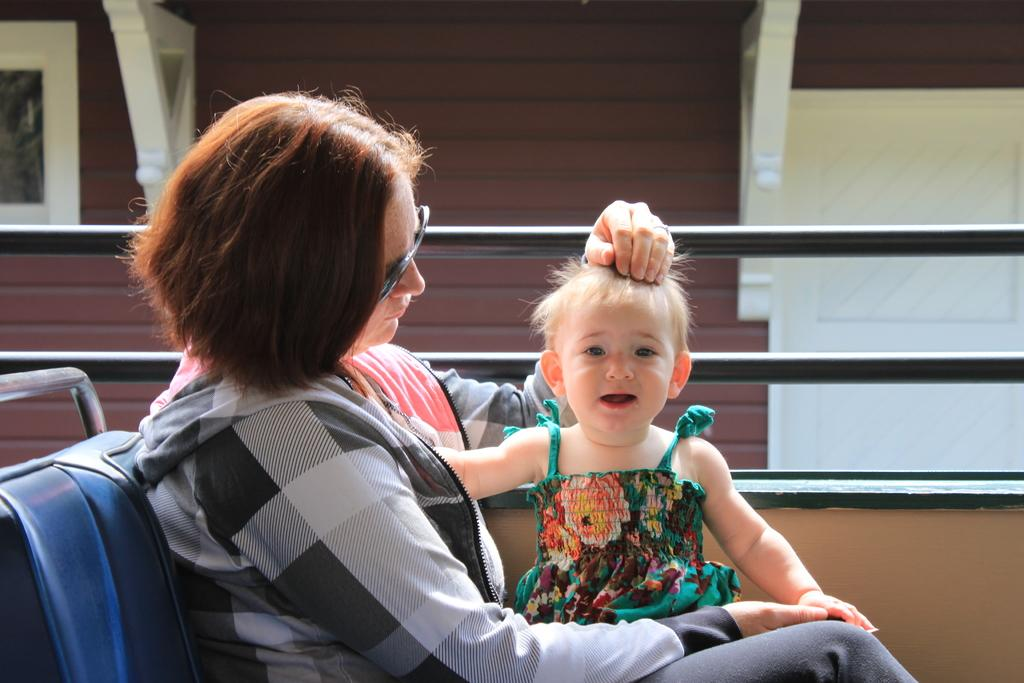Who is present in the image? There is a woman in the image. What is the woman doing in the image? The woman is seated. What accessory is the woman wearing in the image? The woman is wearing spectacles. What else can be seen in the image besides the woman? There is a baby and metal rods in the image. What type of cabbage is being used as a hat in the image? There is no cabbage present in the image, let alone one being used as a hat. 